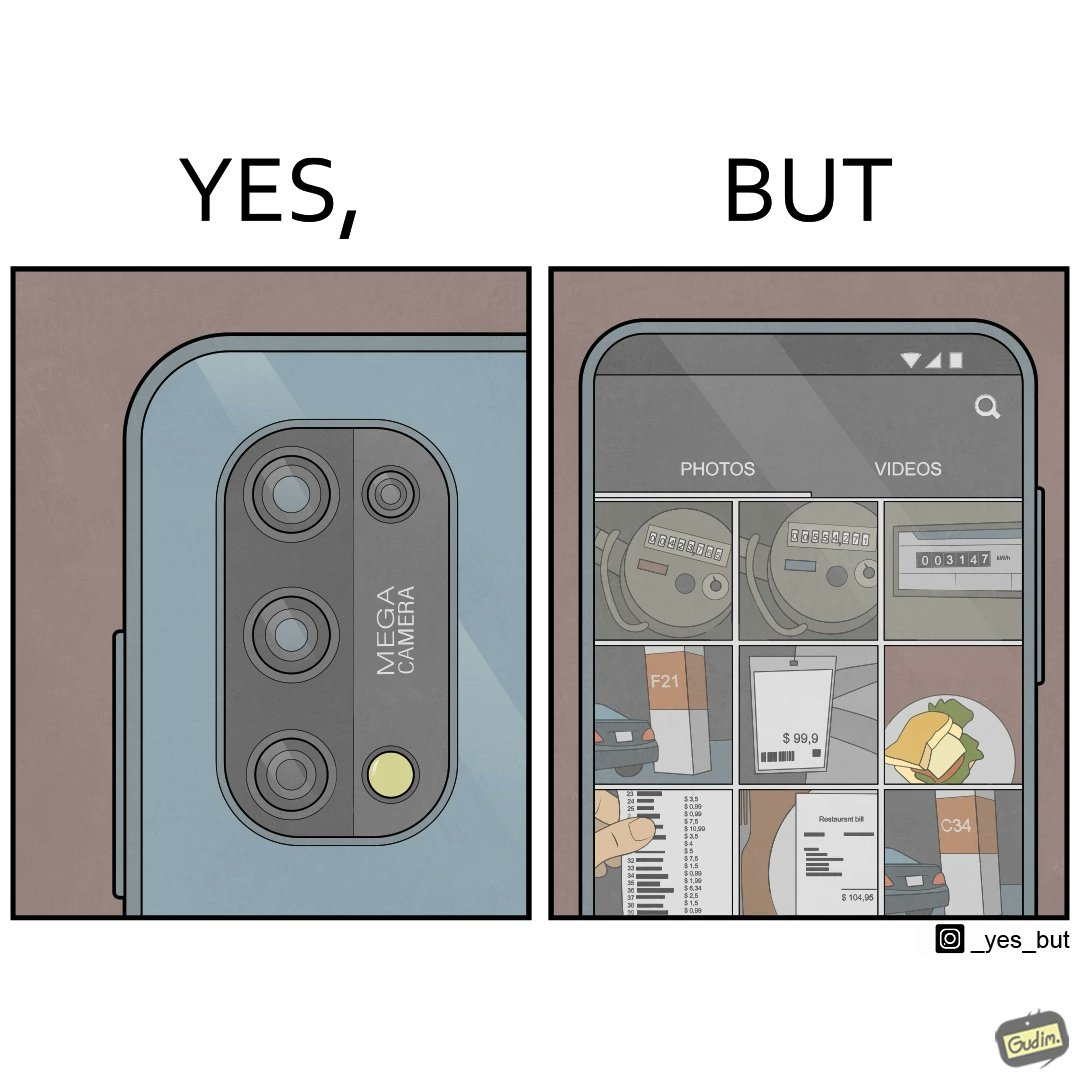Is this image satirical or non-satirical? Yes, this image is satirical. 